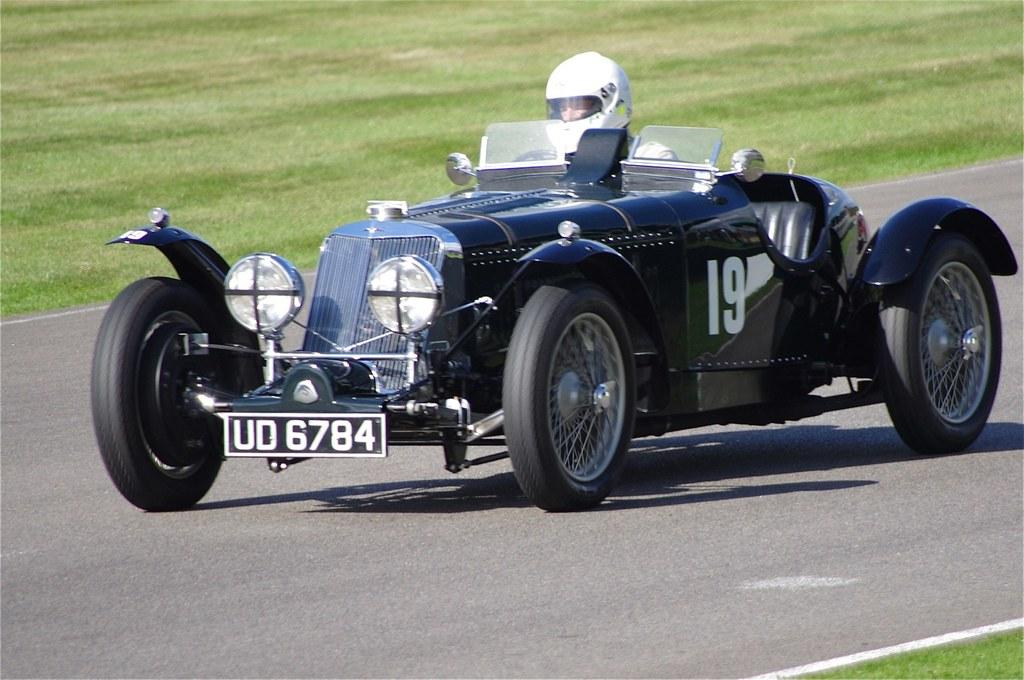What is the main subject of the image? The main subject of the image is a car on the road. Who or what is inside the car? A person is sitting in the car. What safety precaution is the person taking? The person is wearing a helmet. What can be seen on both sides of the road in the image? There is grass on both sides of the road. What type of sheet is being folded by the person in the car? There is no sheet present in the image, and the person is not folding anything. 